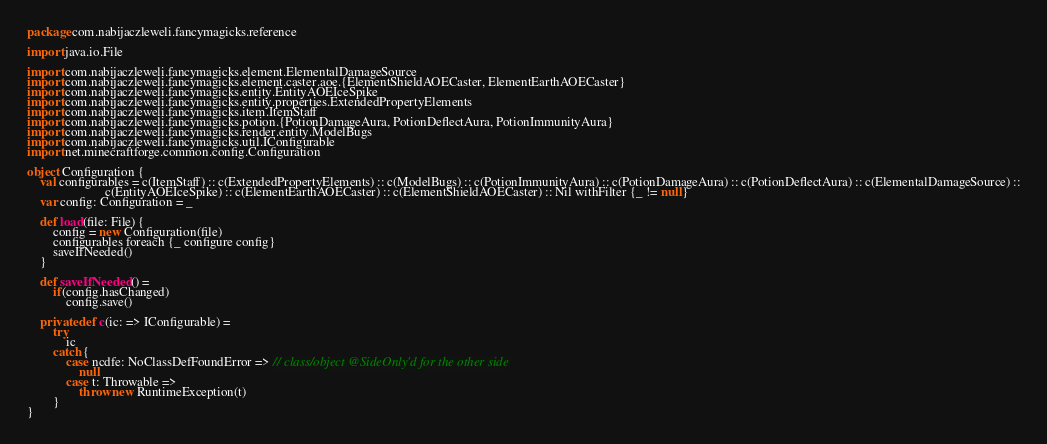Convert code to text. <code><loc_0><loc_0><loc_500><loc_500><_Scala_>package com.nabijaczleweli.fancymagicks.reference

import java.io.File

import com.nabijaczleweli.fancymagicks.element.ElementalDamageSource
import com.nabijaczleweli.fancymagicks.element.caster.aoe.{ElementShieldAOECaster, ElementEarthAOECaster}
import com.nabijaczleweli.fancymagicks.entity.EntityAOEIceSpike
import com.nabijaczleweli.fancymagicks.entity.properties.ExtendedPropertyElements
import com.nabijaczleweli.fancymagicks.item.ItemStaff
import com.nabijaczleweli.fancymagicks.potion.{PotionDamageAura, PotionDeflectAura, PotionImmunityAura}
import com.nabijaczleweli.fancymagicks.render.entity.ModelBugs
import com.nabijaczleweli.fancymagicks.util.IConfigurable
import net.minecraftforge.common.config.Configuration

object Configuration {
	val configurables = c(ItemStaff) :: c(ExtendedPropertyElements) :: c(ModelBugs) :: c(PotionImmunityAura) :: c(PotionDamageAura) :: c(PotionDeflectAura) :: c(ElementalDamageSource) ::
	                    c(EntityAOEIceSpike) :: c(ElementEarthAOECaster) :: c(ElementShieldAOECaster) :: Nil withFilter {_ != null}
	var config: Configuration = _

	def load(file: File) {
		config = new Configuration(file)
		configurables foreach {_ configure config}
		saveIfNeeded()
	}

	def saveIfNeeded() =
		if(config.hasChanged)
			config.save()

	private def c(ic: => IConfigurable) =
		try
			ic
		catch {
			case ncdfe: NoClassDefFoundError => // class/object @SideOnly'd for the other side
				null
			case t: Throwable =>
				throw new RuntimeException(t)
		}
}
</code> 